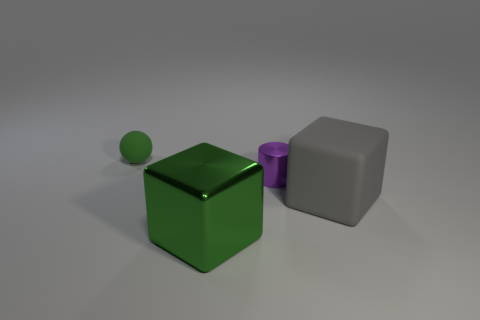There is a rubber thing behind the big thing to the right of the large cube that is to the left of the large gray thing; what is its size?
Offer a terse response. Small. There is a big object that is the same color as the sphere; what is its material?
Provide a short and direct response. Metal. Is there any other thing that has the same shape as the small green matte thing?
Provide a succinct answer. No. There is a gray matte object right of the cube that is on the left side of the small purple shiny object; what size is it?
Keep it short and to the point. Large. How many big things are matte things or matte cubes?
Offer a terse response. 1. Are there fewer tiny cylinders than large purple balls?
Give a very brief answer. No. Is there any other thing that is the same size as the metal cube?
Your answer should be compact. Yes. Do the large metal object and the tiny metallic thing have the same color?
Provide a short and direct response. No. Are there more cyan shiny cubes than large green shiny cubes?
Ensure brevity in your answer.  No. What number of other objects are there of the same color as the matte block?
Your answer should be very brief. 0. 